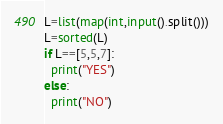<code> <loc_0><loc_0><loc_500><loc_500><_Python_>L=list(map(int,input().split()))
L=sorted(L)
if L==[5,5,7]:
  print("YES")
else:
  print("NO")</code> 